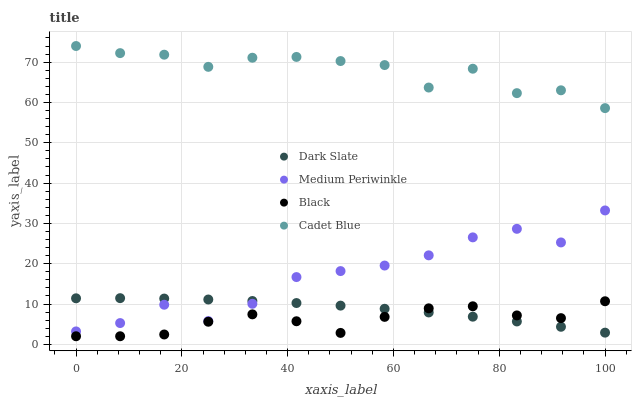Does Black have the minimum area under the curve?
Answer yes or no. Yes. Does Cadet Blue have the maximum area under the curve?
Answer yes or no. Yes. Does Medium Periwinkle have the minimum area under the curve?
Answer yes or no. No. Does Medium Periwinkle have the maximum area under the curve?
Answer yes or no. No. Is Dark Slate the smoothest?
Answer yes or no. Yes. Is Cadet Blue the roughest?
Answer yes or no. Yes. Is Medium Periwinkle the smoothest?
Answer yes or no. No. Is Medium Periwinkle the roughest?
Answer yes or no. No. Does Black have the lowest value?
Answer yes or no. Yes. Does Medium Periwinkle have the lowest value?
Answer yes or no. No. Does Cadet Blue have the highest value?
Answer yes or no. Yes. Does Medium Periwinkle have the highest value?
Answer yes or no. No. Is Black less than Cadet Blue?
Answer yes or no. Yes. Is Cadet Blue greater than Dark Slate?
Answer yes or no. Yes. Does Dark Slate intersect Black?
Answer yes or no. Yes. Is Dark Slate less than Black?
Answer yes or no. No. Is Dark Slate greater than Black?
Answer yes or no. No. Does Black intersect Cadet Blue?
Answer yes or no. No. 